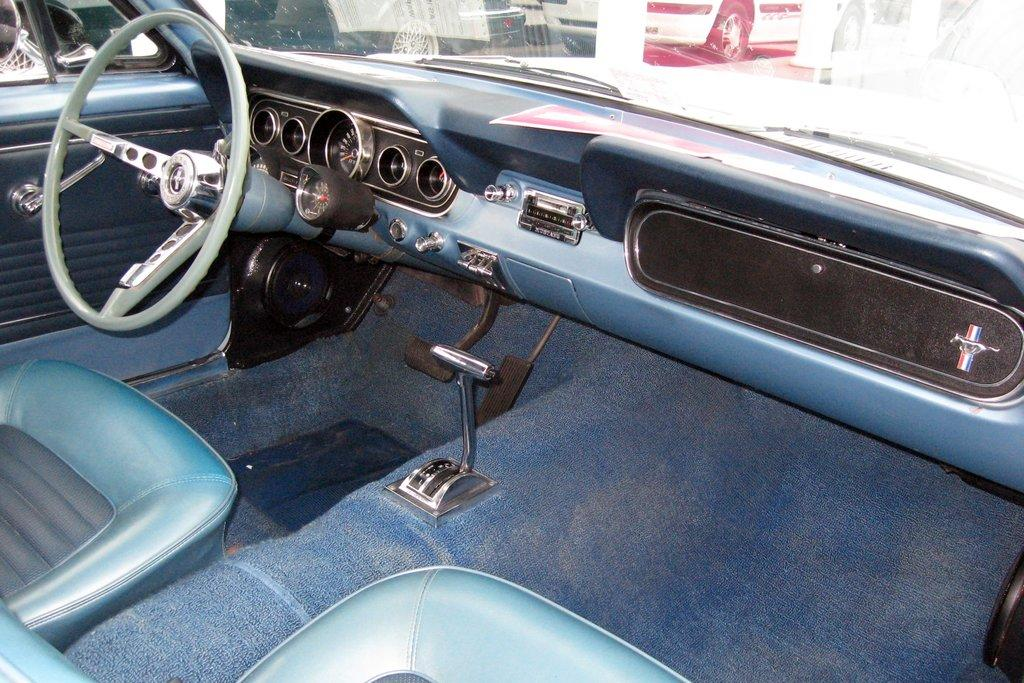What is the setting of the image? The image is of the inside of a car. What can be found on the left side of the car? There is a steering wheel on the left side of the car. What type of rod is being used by the actor in the image? There is no actor or rod present in the image; it is a picture of the inside of a car. 